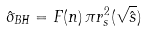Convert formula to latex. <formula><loc_0><loc_0><loc_500><loc_500>\hat { \sigma } _ { B H } = F ( n ) \, \pi r _ { s } ^ { 2 } ( \sqrt { \hat { s } } )</formula> 